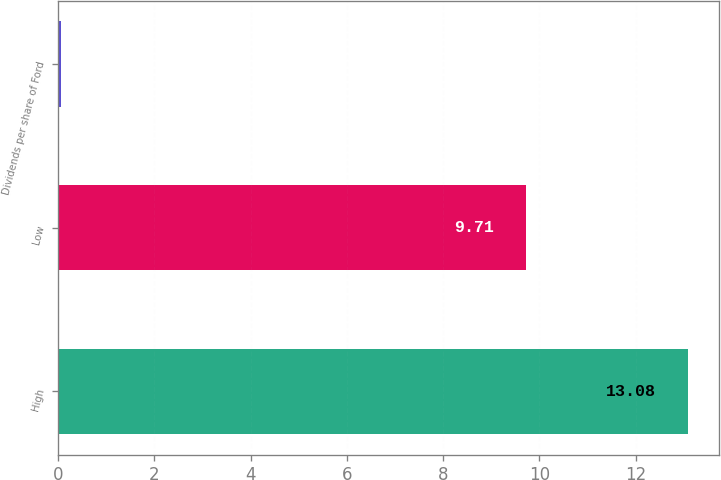Convert chart. <chart><loc_0><loc_0><loc_500><loc_500><bar_chart><fcel>High<fcel>Low<fcel>Dividends per share of Ford<nl><fcel>13.08<fcel>9.71<fcel>0.05<nl></chart> 